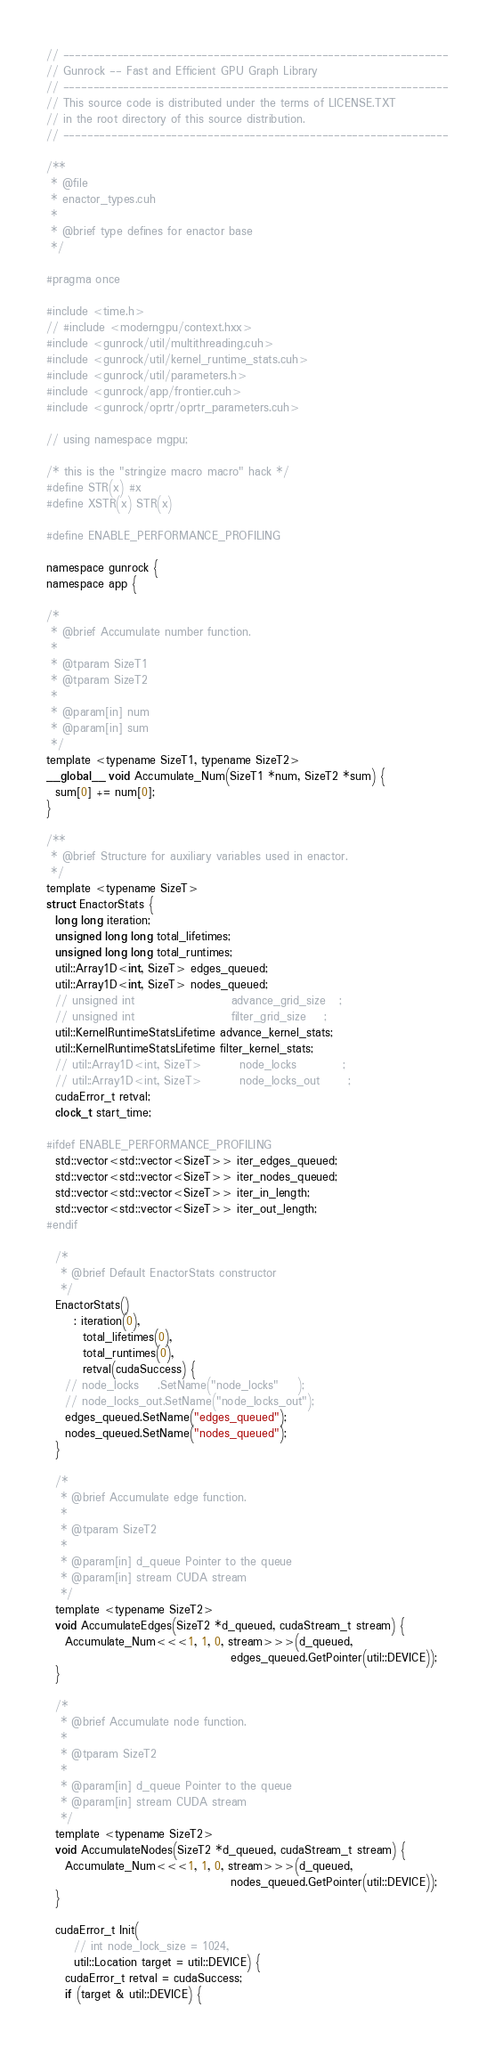<code> <loc_0><loc_0><loc_500><loc_500><_Cuda_>// ----------------------------------------------------------------
// Gunrock -- Fast and Efficient GPU Graph Library
// ----------------------------------------------------------------
// This source code is distributed under the terms of LICENSE.TXT
// in the root directory of this source distribution.
// ----------------------------------------------------------------

/**
 * @file
 * enactor_types.cuh
 *
 * @brief type defines for enactor base
 */

#pragma once

#include <time.h>
// #include <moderngpu/context.hxx>
#include <gunrock/util/multithreading.cuh>
#include <gunrock/util/kernel_runtime_stats.cuh>
#include <gunrock/util/parameters.h>
#include <gunrock/app/frontier.cuh>
#include <gunrock/oprtr/oprtr_parameters.cuh>

// using namespace mgpu;

/* this is the "stringize macro macro" hack */
#define STR(x) #x
#define XSTR(x) STR(x)

#define ENABLE_PERFORMANCE_PROFILING

namespace gunrock {
namespace app {

/*
 * @brief Accumulate number function.
 *
 * @tparam SizeT1
 * @tparam SizeT2
 *
 * @param[in] num
 * @param[in] sum
 */
template <typename SizeT1, typename SizeT2>
__global__ void Accumulate_Num(SizeT1 *num, SizeT2 *sum) {
  sum[0] += num[0];
}

/**
 * @brief Structure for auxiliary variables used in enactor.
 */
template <typename SizeT>
struct EnactorStats {
  long long iteration;
  unsigned long long total_lifetimes;
  unsigned long long total_runtimes;
  util::Array1D<int, SizeT> edges_queued;
  util::Array1D<int, SizeT> nodes_queued;
  // unsigned int                     advance_grid_size   ;
  // unsigned int                     filter_grid_size    ;
  util::KernelRuntimeStatsLifetime advance_kernel_stats;
  util::KernelRuntimeStatsLifetime filter_kernel_stats;
  // util::Array1D<int, SizeT>        node_locks          ;
  // util::Array1D<int, SizeT>        node_locks_out      ;
  cudaError_t retval;
  clock_t start_time;

#ifdef ENABLE_PERFORMANCE_PROFILING
  std::vector<std::vector<SizeT>> iter_edges_queued;
  std::vector<std::vector<SizeT>> iter_nodes_queued;
  std::vector<std::vector<SizeT>> iter_in_length;
  std::vector<std::vector<SizeT>> iter_out_length;
#endif

  /*
   * @brief Default EnactorStats constructor
   */
  EnactorStats()
      : iteration(0),
        total_lifetimes(0),
        total_runtimes(0),
        retval(cudaSuccess) {
    // node_locks    .SetName("node_locks"    );
    // node_locks_out.SetName("node_locks_out");
    edges_queued.SetName("edges_queued");
    nodes_queued.SetName("nodes_queued");
  }

  /*
   * @brief Accumulate edge function.
   *
   * @tparam SizeT2
   *
   * @param[in] d_queue Pointer to the queue
   * @param[in] stream CUDA stream
   */
  template <typename SizeT2>
  void AccumulateEdges(SizeT2 *d_queued, cudaStream_t stream) {
    Accumulate_Num<<<1, 1, 0, stream>>>(d_queued,
                                        edges_queued.GetPointer(util::DEVICE));
  }

  /*
   * @brief Accumulate node function.
   *
   * @tparam SizeT2
   *
   * @param[in] d_queue Pointer to the queue
   * @param[in] stream CUDA stream
   */
  template <typename SizeT2>
  void AccumulateNodes(SizeT2 *d_queued, cudaStream_t stream) {
    Accumulate_Num<<<1, 1, 0, stream>>>(d_queued,
                                        nodes_queued.GetPointer(util::DEVICE));
  }

  cudaError_t Init(
      // int node_lock_size = 1024,
      util::Location target = util::DEVICE) {
    cudaError_t retval = cudaSuccess;
    if (target & util::DEVICE) {</code> 